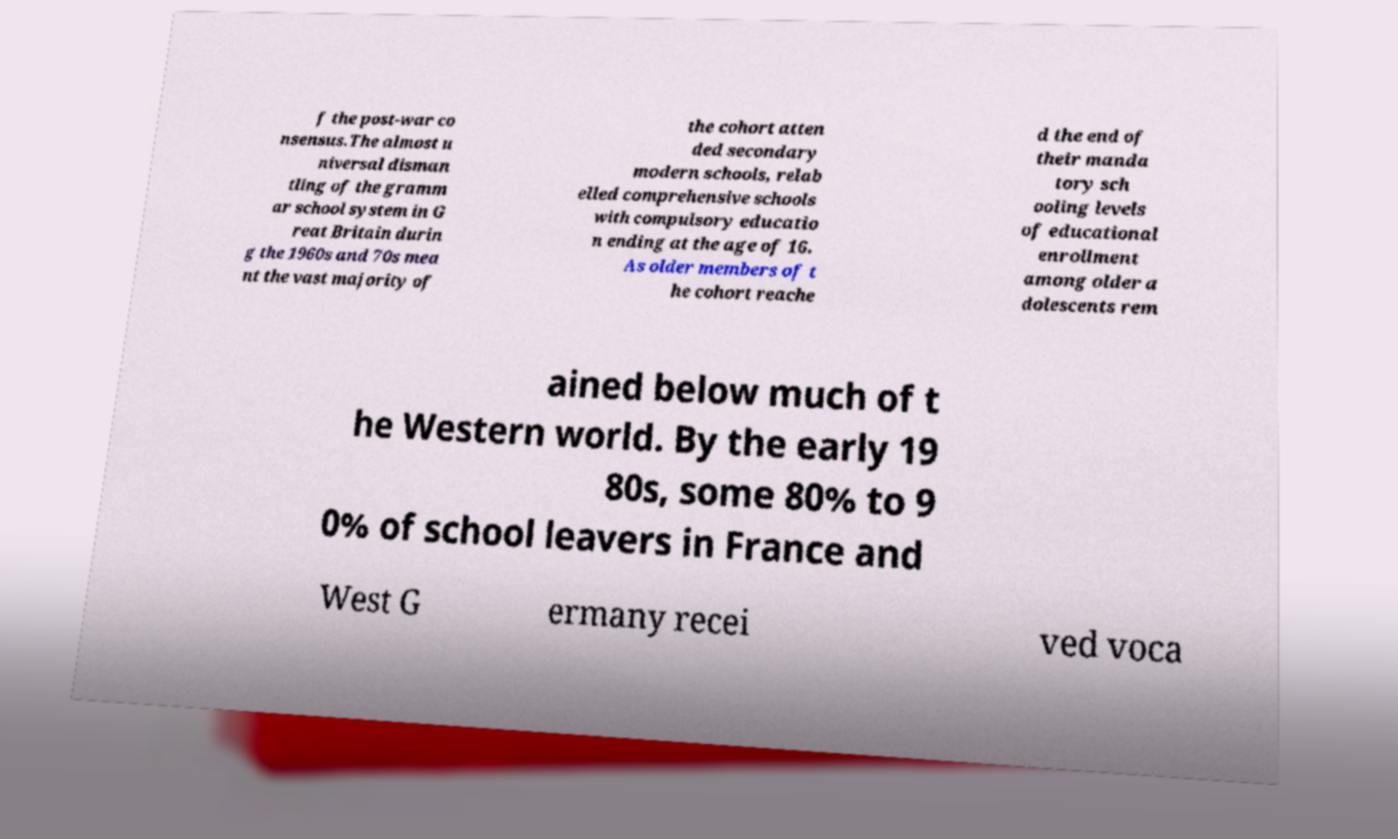Please read and relay the text visible in this image. What does it say? f the post-war co nsensus.The almost u niversal disman tling of the gramm ar school system in G reat Britain durin g the 1960s and 70s mea nt the vast majority of the cohort atten ded secondary modern schools, relab elled comprehensive schools with compulsory educatio n ending at the age of 16. As older members of t he cohort reache d the end of their manda tory sch ooling levels of educational enrollment among older a dolescents rem ained below much of t he Western world. By the early 19 80s, some 80% to 9 0% of school leavers in France and West G ermany recei ved voca 